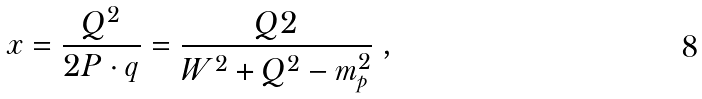Convert formula to latex. <formula><loc_0><loc_0><loc_500><loc_500>x = \frac { Q ^ { 2 } } { 2 P \cdot q } = \frac { Q 2 } { W ^ { 2 } + Q ^ { 2 } - m _ { p } ^ { 2 } } \ ,</formula> 